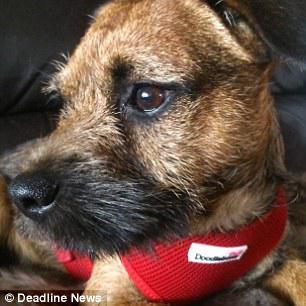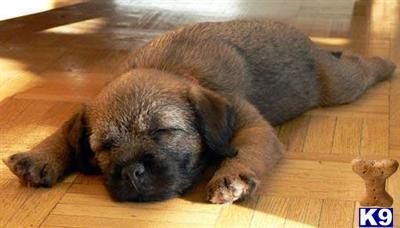The first image is the image on the left, the second image is the image on the right. Evaluate the accuracy of this statement regarding the images: "The dog in the image on the right, he is not laying down.". Is it true? Answer yes or no. No. The first image is the image on the left, the second image is the image on the right. Given the left and right images, does the statement "the dog is laying down on the right side pic" hold true? Answer yes or no. Yes. 